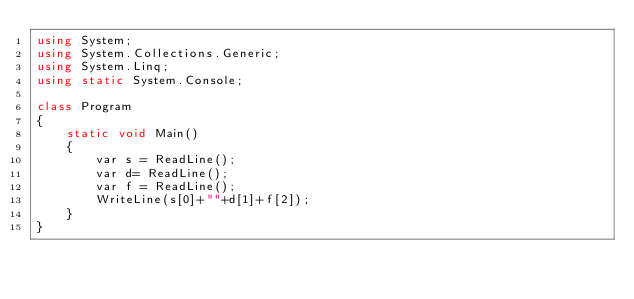Convert code to text. <code><loc_0><loc_0><loc_500><loc_500><_C#_>using System;
using System.Collections.Generic;
using System.Linq;
using static System.Console;

class Program
{
    static void Main()
    {
        var s = ReadLine();
        var d= ReadLine();
        var f = ReadLine();
        WriteLine(s[0]+""+d[1]+f[2]);
    }
}</code> 